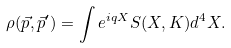<formula> <loc_0><loc_0><loc_500><loc_500>\rho ( \vec { p } , \vec { p } ^ { \prime } ) = \int e ^ { i q X } S ( X , K ) d ^ { 4 } X .</formula> 